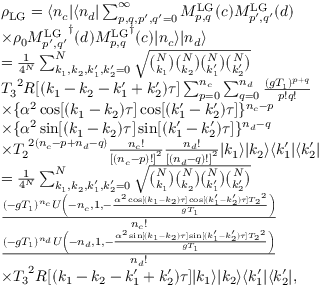Convert formula to latex. <formula><loc_0><loc_0><loc_500><loc_500>\begin{array} { r l } & { \rho _ { L G } = \langle n _ { c } | \langle n _ { d } | \sum _ { p , q , p ^ { \prime } , q ^ { \prime } = 0 } ^ { \infty } M _ { p , q } ^ { L G } ( c ) M _ { p ^ { \prime } , q ^ { \prime } } ^ { L G } ( d ) } \\ & { \times \rho _ { 0 } { M _ { p ^ { \prime } , q ^ { \prime } } ^ { L G } } ^ { \dagger } ( d ) { M _ { p , q } ^ { L G } } ^ { \dagger } ( c ) | n _ { c } \rangle | n _ { d } \rangle } \\ & { = \frac { 1 } { 4 ^ { N } } \sum _ { k _ { 1 } , k _ { 2 } , k _ { 1 } ^ { \prime } , k _ { 2 } ^ { \prime } = 0 } ^ { N } \sqrt { \binom { N } { k _ { 1 } } \binom { N } { k _ { 2 } } \binom { N } { k _ { 1 } ^ { \prime } } \binom { N } { k _ { 2 } ^ { \prime } } } } \\ & { { T _ { 3 } } ^ { 2 } R [ ( k _ { 1 } - k _ { 2 } - k _ { 1 } ^ { \prime } + k _ { 2 } ^ { \prime } ) \tau ] \sum _ { p = 0 } ^ { n _ { c } } \sum _ { q = 0 } ^ { n _ { d } } \frac { ( g T _ { 1 } ) ^ { p + q } } { p ! q ! } } \\ & { \times \{ \alpha ^ { 2 } \cos [ ( k _ { 1 } - k _ { 2 } ) \tau ] \cos [ ( k _ { 1 } ^ { \prime } - k _ { 2 } ^ { \prime } ) \tau ] \} ^ { n _ { c } - p } } \\ & { \times \{ \alpha ^ { 2 } \sin [ ( k _ { 1 } - k _ { 2 } ) \tau ] \sin [ ( k _ { 1 } ^ { \prime } - k _ { 2 } ^ { \prime } ) \tau ] \} ^ { n _ { d } - q } } \\ & { \times { T _ { 2 } } ^ { 2 ( n _ { c } - p + n _ { d } - q ) } \frac { n _ { c } ! } { { [ ( n _ { c } - p ) ! ] } ^ { 2 } } \frac { n _ { d } ! } { { [ ( n _ { d } - q ) ! ] } ^ { 2 } } | k _ { 1 } \rangle | k _ { 2 } \rangle \langle k _ { 1 } ^ { \prime } | \langle k _ { 2 } ^ { \prime } | } \\ & { = \frac { 1 } { 4 ^ { N } } \sum _ { k _ { 1 } , k _ { 2 } , k _ { 1 } ^ { \prime } , k _ { 2 } ^ { \prime } = 0 } ^ { N } \sqrt { \binom { N } { k _ { 1 } } \binom { N } { k _ { 2 } } \binom { N } { k _ { 1 } ^ { \prime } } \binom { N } { k _ { 2 } ^ { \prime } } } } \\ & { \frac { ( - g { T _ { 1 } } ) ^ { { n _ { c } } } U \left ( - { n _ { c } } , 1 , - \frac { \alpha ^ { 2 } \cos [ ( { k _ { 1 } } - { k _ { 2 } } ) \tau ] \cos [ ( { k _ { 1 } ^ { \prime } } - { k _ { 2 } ^ { \prime } } ) \tau ] { T _ { 2 } } ^ { 2 } } { g { T _ { 1 } } } \right ) } { { n _ { c } } ! } } \\ & { \frac { ( - g { T _ { 1 } } ) ^ { { n _ { d } } } U \left ( - { n _ { d } } , 1 , - \frac { \alpha ^ { 2 } \sin [ ( { k _ { 1 } } - { k _ { 2 } } ) \tau ] \sin [ ( { k _ { 1 } ^ { \prime } } - { k _ { 2 } ^ { \prime } } ) \tau ] { T _ { 2 } } ^ { 2 } } { g { T _ { 1 } } } \right ) } { { n _ { d } } ! } } \\ & { \times { T _ { 3 } } ^ { 2 } R [ ( k _ { 1 } - k _ { 2 } - k _ { 1 } ^ { \prime } + k _ { 2 } ^ { \prime } ) \tau ] | k _ { 1 } \rangle | k _ { 2 } \rangle \langle k _ { 1 } ^ { \prime } | \langle k _ { 2 } ^ { \prime } | , } \end{array}</formula> 